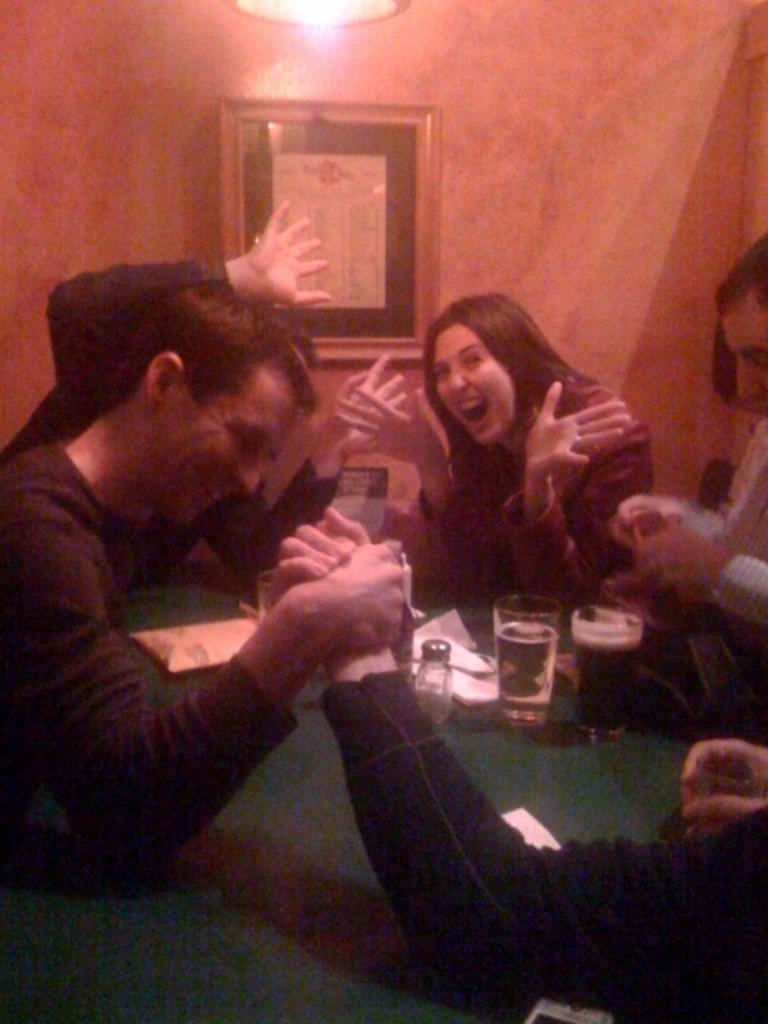How many people are present in the image? There are persons in the image, but the exact number cannot be determined from the provided facts. What is on the table in the image? There are glasses and papers on the table in the image. What can be seen in the background of the image? There is a wall and a frame in the background of the image. What type of lighting is present in the image? There is a light in the image. What type of hobbies are the persons in the image engaged in? The provided facts do not mention any specific hobbies or activities that the persons in the image are engaged in. 